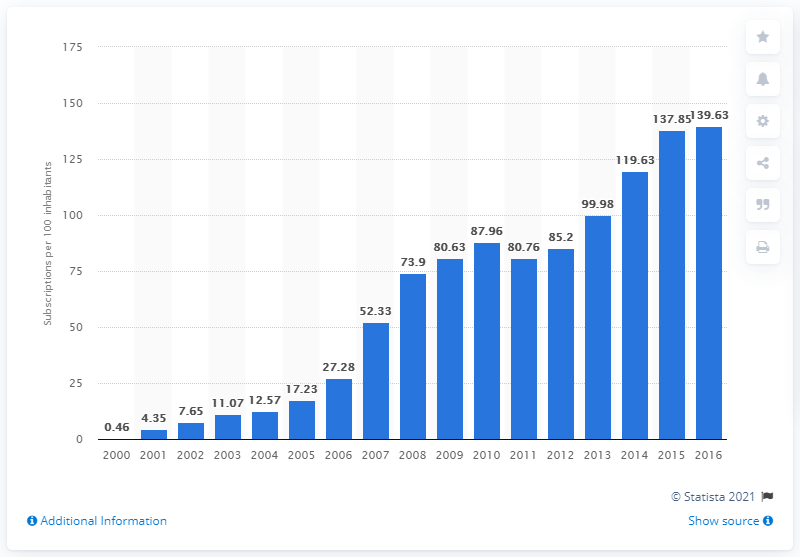Identify some key points in this picture. In Gambia between 2000 and 2016, there were an average of 139.63 mobile cellular subscriptions for every 100 people. 